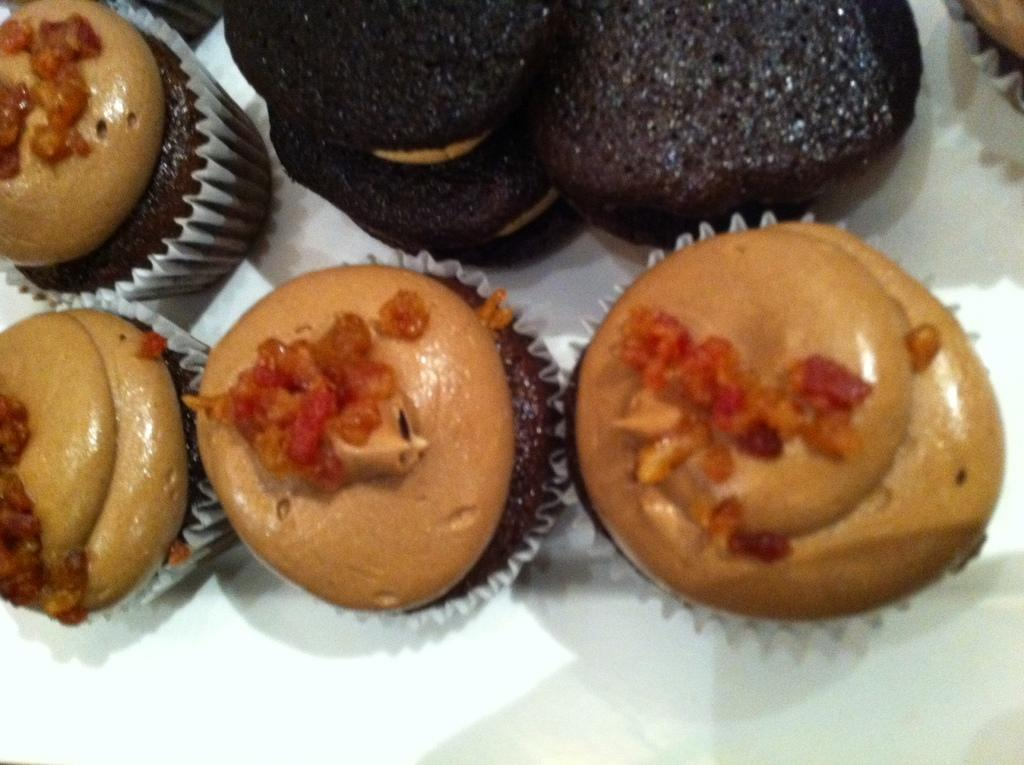What type of desserts can be seen in the image? There are cupcakes and cookies in the image. Where are the cupcakes and cookies located? Both cupcakes and cookies are present on a table. What type of lift is used to transport the cupcakes and cookies in the image? There is no lift present in the image; the cupcakes and cookies are on a table. 